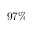<formula> <loc_0><loc_0><loc_500><loc_500>9 7 \%</formula> 